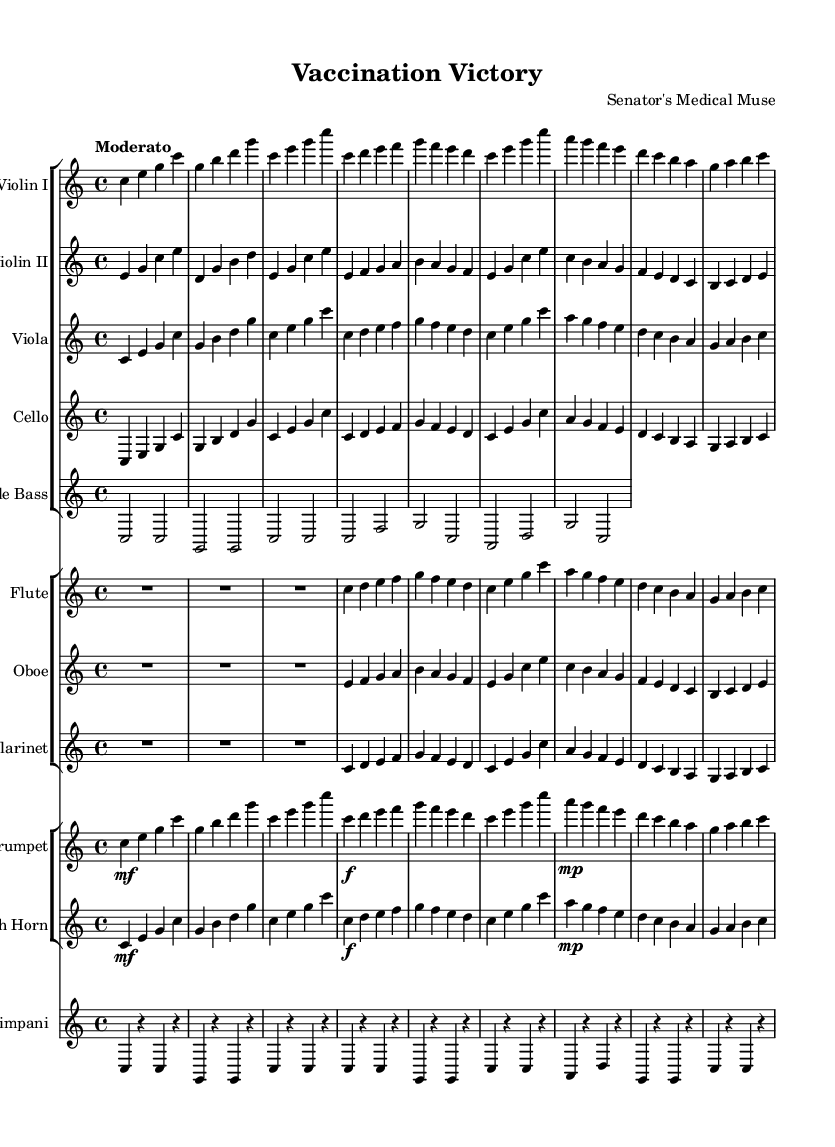What is the key signature of this music? The key signature is C major, which is indicated at the beginning of the score and has no sharps or flats.
Answer: C major What is the time signature of this music? The time signature is found at the beginning of the score; it displays a 4 over 4, indicating four beats per measure.
Answer: 4/4 What is the tempo marking for this piece? The tempo marking is specified as "Moderato" at the beginning of the score, indicating a moderate speed.
Answer: Moderato How many measures are in the piece? By counting each measure notated in the score, we can determine the total. There are 15 measures in total.
Answer: 15 Which instruments are included in the orchestration? The orchestration includes Violin I, Violin II, Viola, Cello, Double Bass, Flute, Oboe, Clarinet, Trumpet, French Horn, and Timpani as specified by the instrument names in the score.
Answer: Violin I, Violin II, Viola, Cello, Double Bass, Flute, Oboe, Clarinet, Trumpet, French Horn, Timpani What is the dynamic marking for the trumpet part in measure 1? The dynamic marking is indicated by the symbol 'mf' which stands for mezzo-forte; this indicates a moderately loud dynamic.
Answer: mf Which section of the orchestra has the long rest at the beginning? The rest is specified for the Flute, which indicates a long pause before the instrument enters in the score.
Answer: Flute 